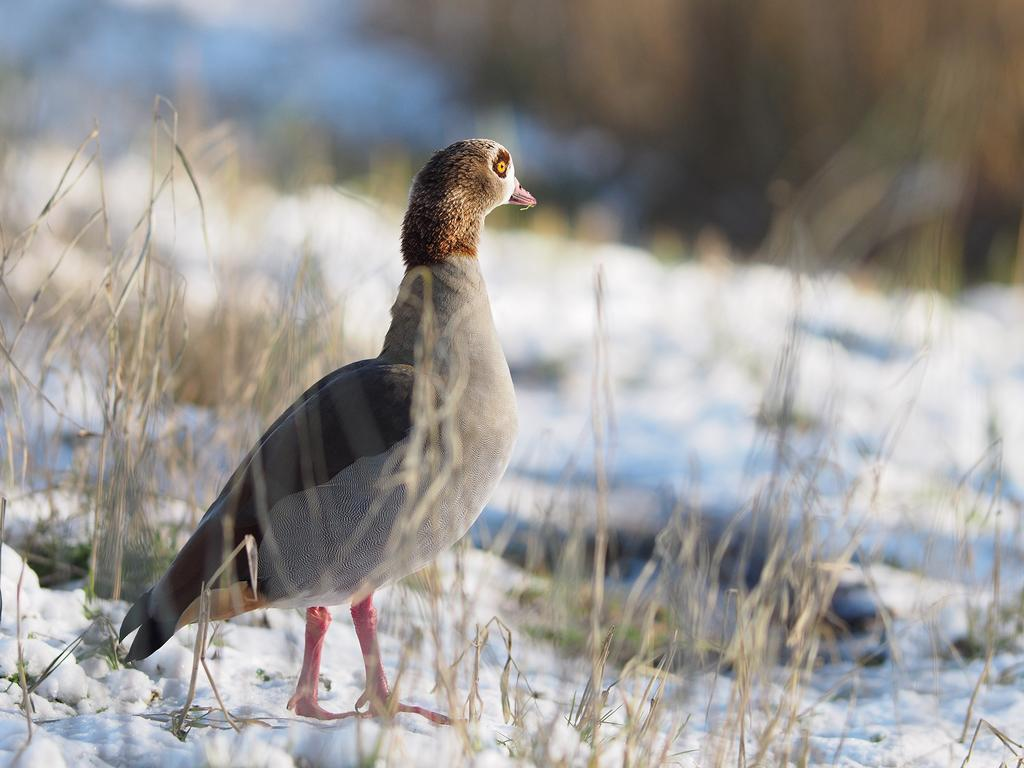What type of animal can be seen in the image? There is a bird in the image. Where is the bird located in the image? The bird is standing on the snow. What can be seen in the background of the image? There are plants and grass visible in the background of the image. What type of terrain is visible at the bottom of the image? There is snow visible at the bottom of the image. Where can the store be found in the image? There is no store present in the image. What type of butter is the bird using to respect the snow? The bird is not using butter, and there is no indication of respect in the image. 